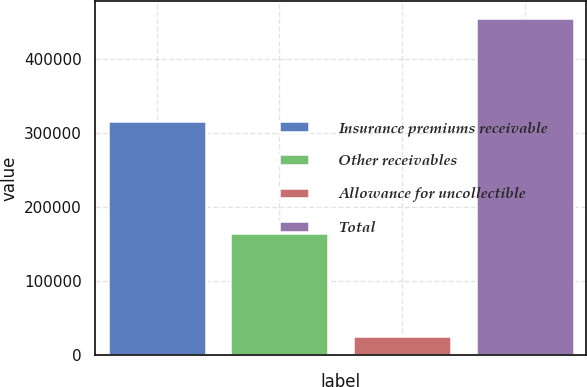Convert chart to OTSL. <chart><loc_0><loc_0><loc_500><loc_500><bar_chart><fcel>Insurance premiums receivable<fcel>Other receivables<fcel>Allowance for uncollectible<fcel>Total<nl><fcel>316238<fcel>163885<fcel>25334<fcel>454789<nl></chart> 